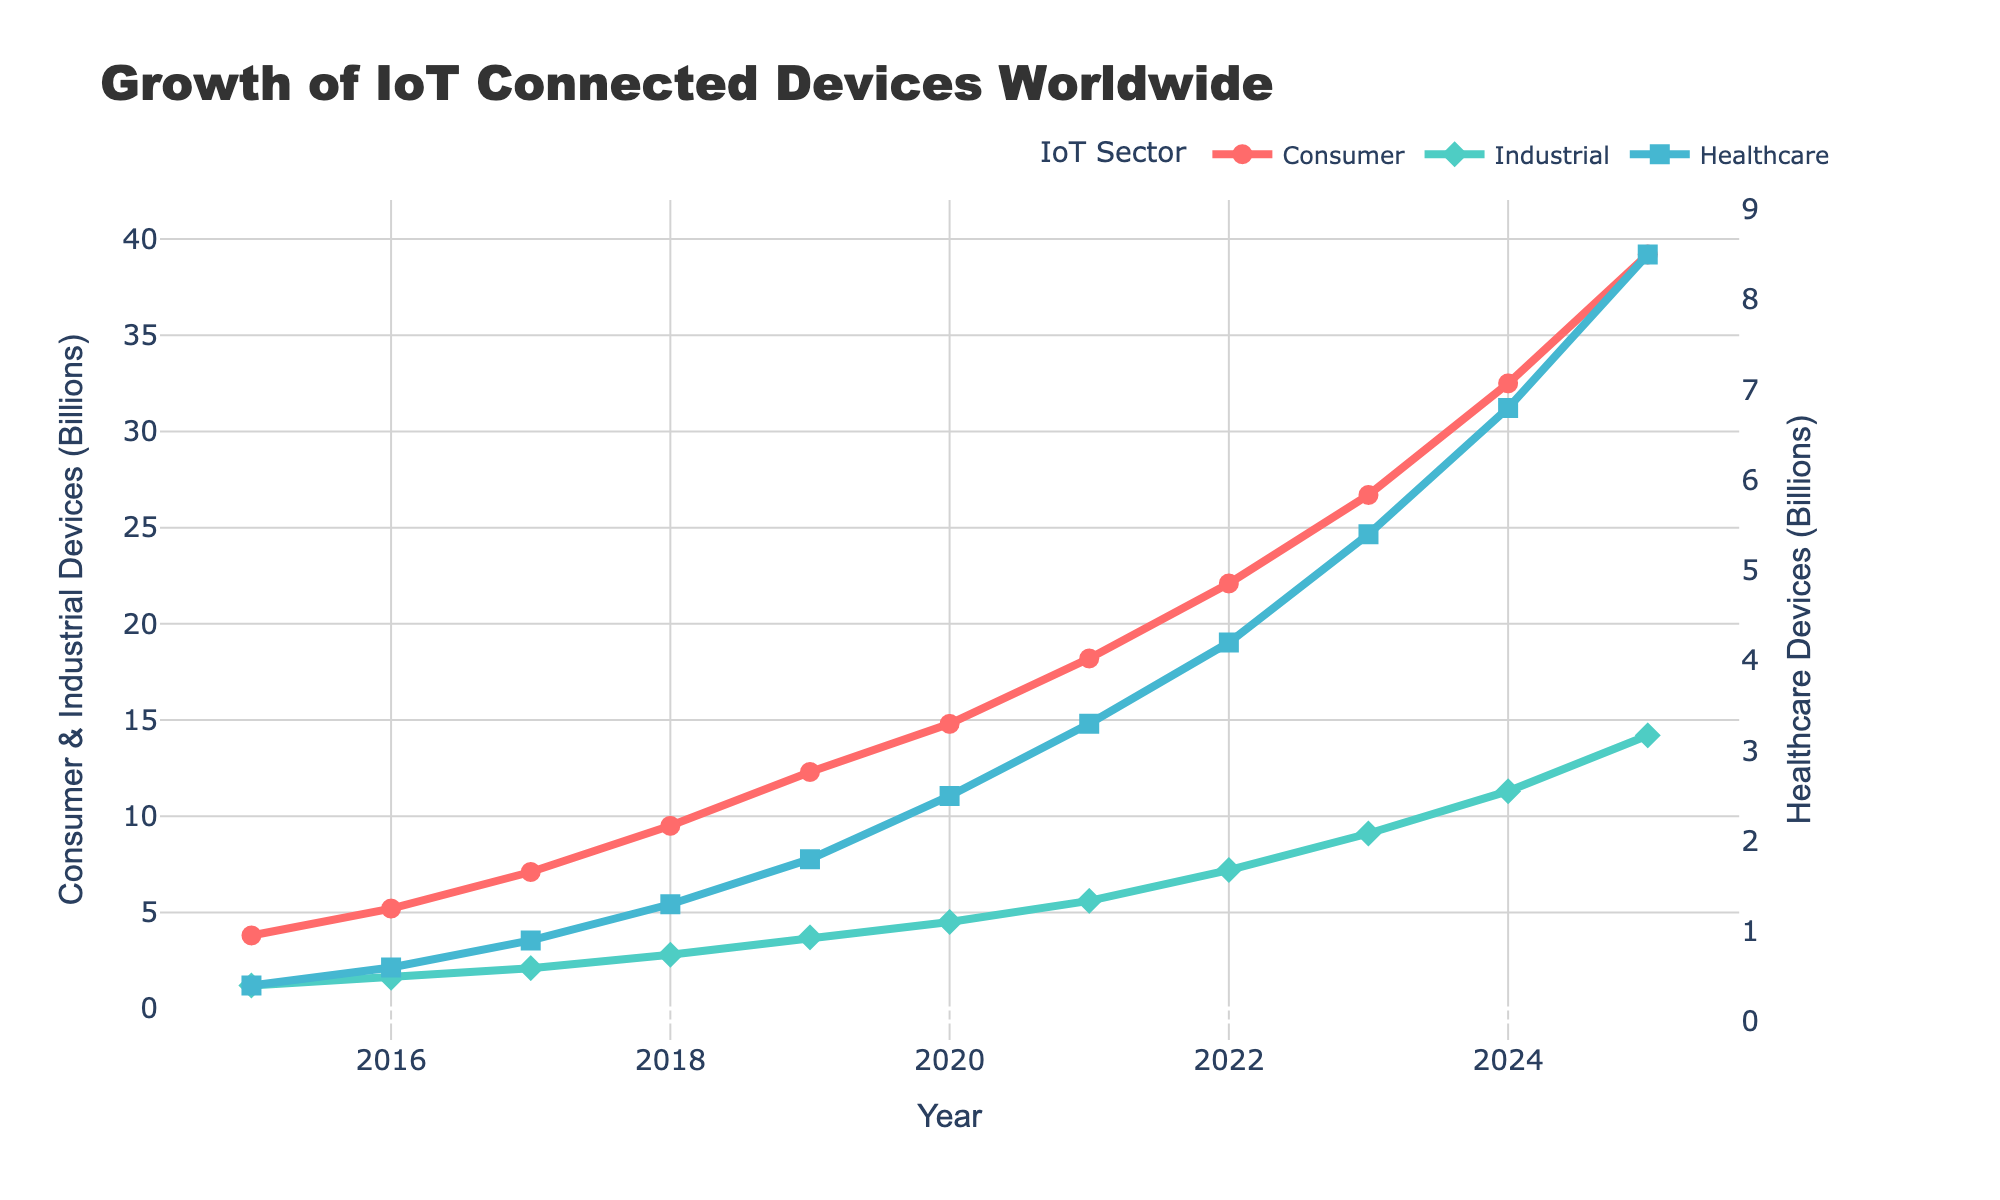What is the total number of IoT connected devices (sum of Consumer, Industrial, and Healthcare) in 2020? Sum the number of Consumer, Industrial, and Healthcare IoT devices for the year 2020. Consumer: 14.8 billion, Industrial: 4.5 billion, Healthcare: 2.5 billion. Total = 14.8 + 4.5 + 2.5 = 21.8 billion
Answer: 21.8 billion Which category of IoT devices has the highest growth from 2015 to 2025? Calculate the difference for each category between 2025 and 2015. Consumer: 39.2 - 3.8 = 35.4 billion, Industrial: 14.2 - 1.2 = 13 billion, Healthcare: 8.5 - 0.4 = 8.1 billion. The highest difference is in Consumer IoT devices
Answer: Consumer IoT devices How does the number of Consumer IoT devices in 2017 compare to Industrial IoT devices in 2021? Look at the chart and read the values for each category in the respective years. Consumer IoT devices in 2017: 7.1 billion, Industrial IoT devices in 2021: 5.6 billion. 7.1 billion (Consumer) is greater than 5.6 billion (Industrial)
Answer: Consumer IoT devices are greater What is the rate of increase in Healthcare IoT devices from 2018 to 2020? Calculate the difference between 2020 and 2018 for Healthcare IoT devices and divide by the number of years between these two: (2.5 - 1.3) billion / 2 years = 1.2/2 = 0.6 billion/year
Answer: 0.6 billion/year Which year sees the smallest increase in Industrial IoT devices? Verify each year's difference by comparing subsequent years. 2015-2016: 1.6 - 1.2 = 0.4 billion, 2016-2017: 2.1 - 1.6 = 0.5 billion, 2017-2018: 2.8 - 2.1 = 0.7 billion, 2018-2019: 3.7 - 2.8 = 0.9 billion, 2019-2020: 4.5 - 3.7 = 0.8 billion, 2020-2021: 5.6 - 4.5 = 1.1 billion, 2021-2022: 7.2 - 5.6 = 1.6 billion, 2022-2023: 9.1 - 7.2 = 1.9 billion, 2023-2024: 11.3 - 9.1 = 2.2 billion, 2024-2025: 14.2 - 11.3 = 2.9 billion. The smallest increase is from 2015-2016 (0.4 billion)
Answer: Between 2015-2016 Which category shows the steepest increase in devices over the years, based on the line chart's visual slope? Check the slopes of the lines in the chart. The red (Consumer IoT) line has the steepest slope, indicating the highest increase in devices over the years
Answer: Consumer IoT devices By how much did the total number of IoT devices (all categories combined) increase from 2019 to 2023? Sum of all categories in 2019: 12.3 + 3.7 + 1.8 = 17.8 billion. Sum in 2023: 26.7 + 9.1 + 5.4 = 41.2 billion. Increase is 41.2 - 17.8 = 23.4 billion
Answer: 23.4 billion Which year did the number of Consumer IoT devices exceed double the number of Healthcare IoT devices? For each year, compare Consumer IoT devices with twice the number of Healthcare IoT devices. 2015: 3.8 not > 2*0.4 = 0.8, 2016: 5.2 not > 2*0.6 = 1.2, 2017: 7.1 not > 2*0.9 = 1.8, 2018: 9.5 > 2*1.3 = 2.6, 2019: 12.3 > 2*1.8 = 3.6, 2020: 14.8 > 2*2.5 = 5, 2021: 18.2 > 2*3.3 = 6.6, 2022: 22.1 > 2*4.2 = 8.4, 2023: 26.7 > 2*5.4 = 10.8, 2024: 32.5 > 2*6.8 = 13.6, 2025: 39.2 > 2*8.5 = 17. First year when Consumer IoT exceeds double Healthcare IoT is 2018
Answer: 2018 